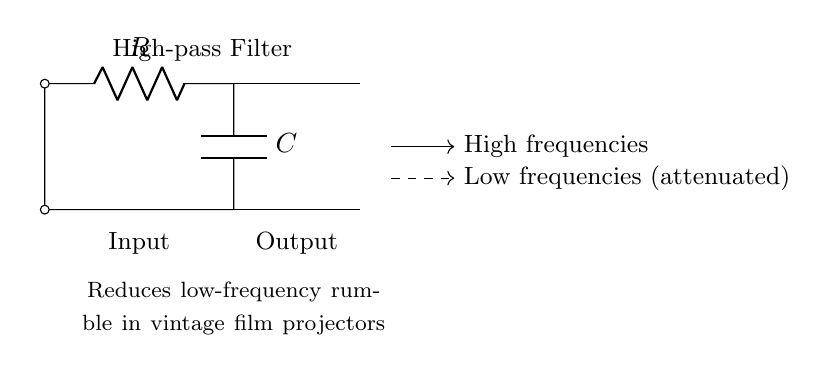What type of filter is shown in the diagram? The circuit is identified as a high-pass filter, which allows high frequencies to pass while attenuating low frequencies.
Answer: High-pass filter What are the components used in this circuit? The circuit includes a resistor and a capacitor, which are essential for its filtering functionality.
Answer: Resistor and Capacitor What is the main function of this high-pass filter? The primary purpose of this high-pass filter is to reduce low-frequency rumble, particularly in vintage film projectors, improving audio quality.
Answer: Reduces low-frequency rumble What happens to low frequencies in this circuit? The low frequencies are attenuated, meaning they are significantly reduced in amplitude as they pass through the filter.
Answer: Attenuated What are the two outputs indicated in the diagram? The outputs shown in the diagram are high frequencies, which pass through, and low frequencies, which are either attenuated or blocked.
Answer: High frequencies and low frequencies How does the arrangement of components affect the filtering? The arrangement of the resistor and capacitor determines the cutoff frequency of the high-pass filter, influencing which frequencies are allowed to pass and which are reduced.
Answer: Affects cutoff frequency 